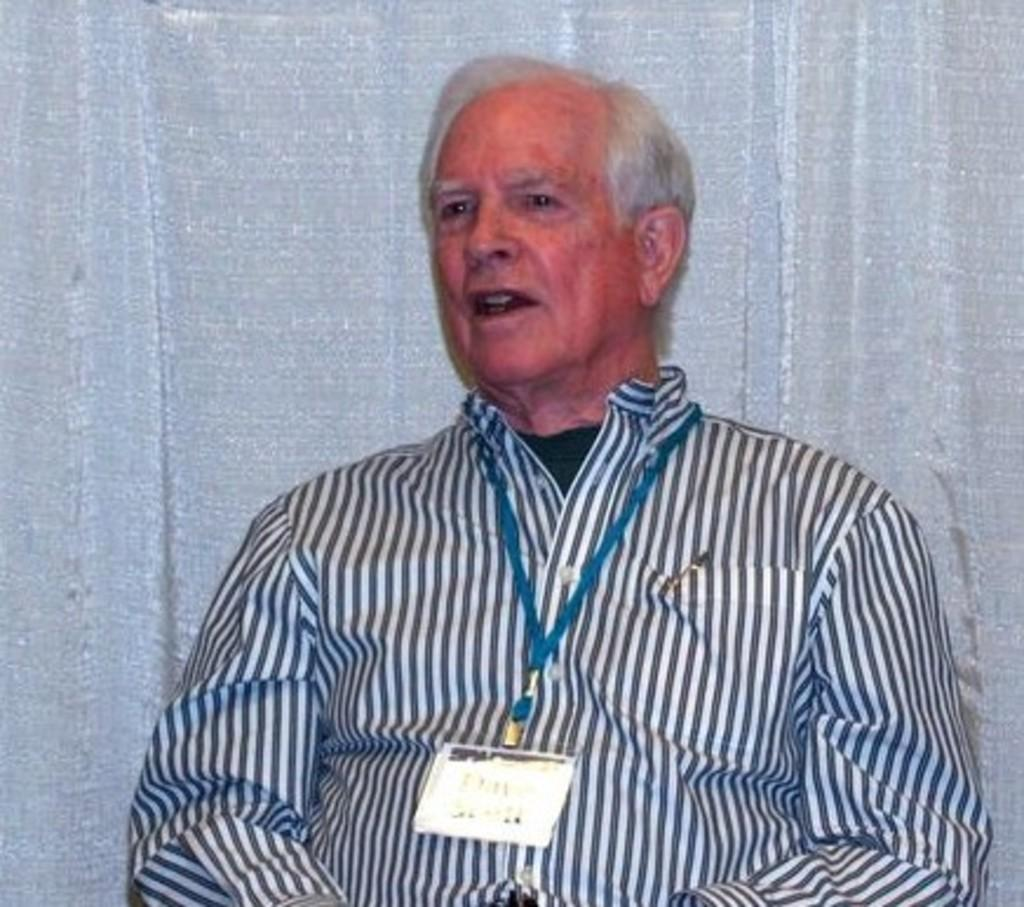What is the main subject of the image? There is a man in the image. What is the man doing in the image? The man is sitting. How many legs does the chicken have in the image? There is no chicken present in the image. What is the man using to separate the yoke in the image? There is no yoke or separation process depicted in the image. 